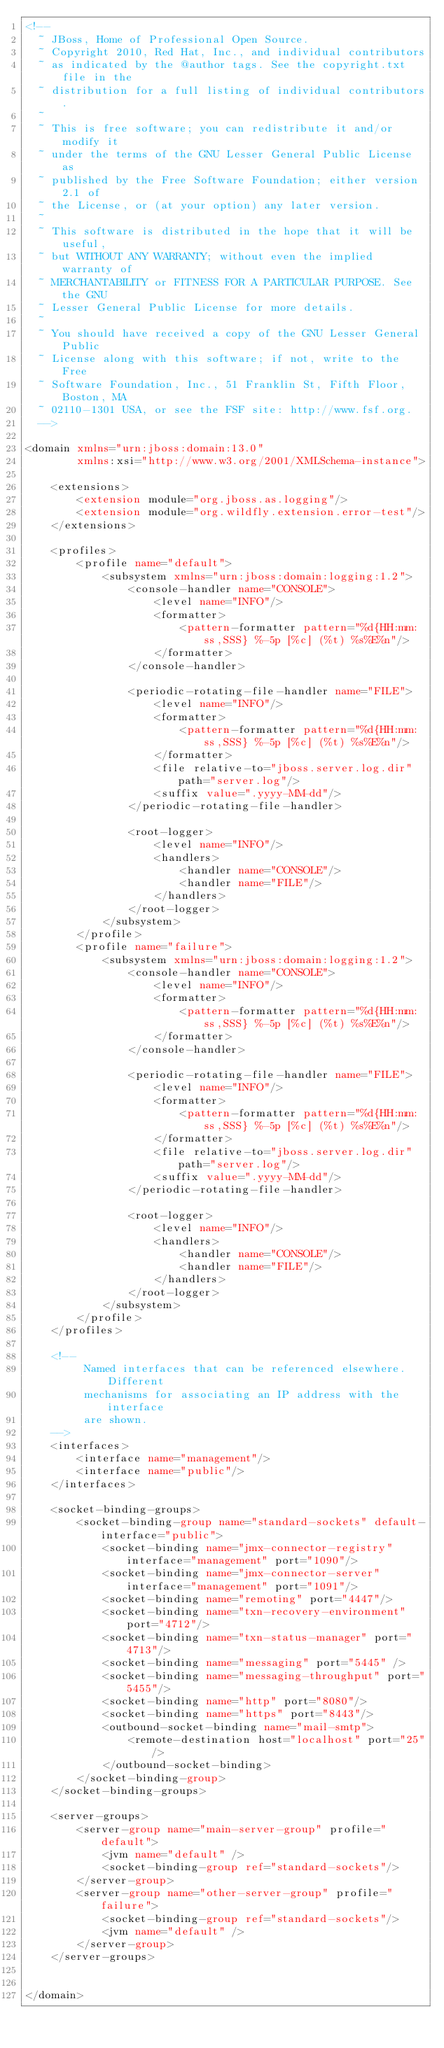Convert code to text. <code><loc_0><loc_0><loc_500><loc_500><_XML_><!--
  ~ JBoss, Home of Professional Open Source.
  ~ Copyright 2010, Red Hat, Inc., and individual contributors
  ~ as indicated by the @author tags. See the copyright.txt file in the
  ~ distribution for a full listing of individual contributors.
  ~
  ~ This is free software; you can redistribute it and/or modify it
  ~ under the terms of the GNU Lesser General Public License as
  ~ published by the Free Software Foundation; either version 2.1 of
  ~ the License, or (at your option) any later version.
  ~
  ~ This software is distributed in the hope that it will be useful,
  ~ but WITHOUT ANY WARRANTY; without even the implied warranty of
  ~ MERCHANTABILITY or FITNESS FOR A PARTICULAR PURPOSE. See the GNU
  ~ Lesser General Public License for more details.
  ~
  ~ You should have received a copy of the GNU Lesser General Public
  ~ License along with this software; if not, write to the Free
  ~ Software Foundation, Inc., 51 Franklin St, Fifth Floor, Boston, MA
  ~ 02110-1301 USA, or see the FSF site: http://www.fsf.org.
  -->

<domain xmlns="urn:jboss:domain:13.0"
        xmlns:xsi="http://www.w3.org/2001/XMLSchema-instance">

    <extensions>
        <extension module="org.jboss.as.logging"/>
        <extension module="org.wildfly.extension.error-test"/>
    </extensions>

    <profiles>
        <profile name="default">
            <subsystem xmlns="urn:jboss:domain:logging:1.2">
                <console-handler name="CONSOLE">
                    <level name="INFO"/>
                    <formatter>
                        <pattern-formatter pattern="%d{HH:mm:ss,SSS} %-5p [%c] (%t) %s%E%n"/>
                    </formatter>
                </console-handler>

                <periodic-rotating-file-handler name="FILE">
                    <level name="INFO"/>
                    <formatter>
                        <pattern-formatter pattern="%d{HH:mm:ss,SSS} %-5p [%c] (%t) %s%E%n"/>
                    </formatter>
                    <file relative-to="jboss.server.log.dir" path="server.log"/>
                    <suffix value=".yyyy-MM-dd"/>
                </periodic-rotating-file-handler>

                <root-logger>
                    <level name="INFO"/>
                    <handlers>
                        <handler name="CONSOLE"/>
                        <handler name="FILE"/>
                    </handlers>
                </root-logger>
            </subsystem>
        </profile>
        <profile name="failure">
            <subsystem xmlns="urn:jboss:domain:logging:1.2">
                <console-handler name="CONSOLE">
                    <level name="INFO"/>
                    <formatter>
                        <pattern-formatter pattern="%d{HH:mm:ss,SSS} %-5p [%c] (%t) %s%E%n"/>
                    </formatter>
                </console-handler>

                <periodic-rotating-file-handler name="FILE">
                    <level name="INFO"/>
                    <formatter>
                        <pattern-formatter pattern="%d{HH:mm:ss,SSS} %-5p [%c] (%t) %s%E%n"/>
                    </formatter>
                    <file relative-to="jboss.server.log.dir" path="server.log"/>
                    <suffix value=".yyyy-MM-dd"/>
                </periodic-rotating-file-handler>

                <root-logger>
                    <level name="INFO"/>
                    <handlers>
                        <handler name="CONSOLE"/>
                        <handler name="FILE"/>
                    </handlers>
                </root-logger>
            </subsystem>
        </profile>
    </profiles>

    <!--
         Named interfaces that can be referenced elsewhere. Different
         mechanisms for associating an IP address with the interface
         are shown.
    -->
    <interfaces>
        <interface name="management"/>
        <interface name="public"/>
    </interfaces>

    <socket-binding-groups>
        <socket-binding-group name="standard-sockets" default-interface="public">
            <socket-binding name="jmx-connector-registry" interface="management" port="1090"/>
            <socket-binding name="jmx-connector-server" interface="management" port="1091"/>
            <socket-binding name="remoting" port="4447"/>
            <socket-binding name="txn-recovery-environment" port="4712"/>
            <socket-binding name="txn-status-manager" port="4713"/>
            <socket-binding name="messaging" port="5445" />
            <socket-binding name="messaging-throughput" port="5455"/>
            <socket-binding name="http" port="8080"/>
            <socket-binding name="https" port="8443"/>
            <outbound-socket-binding name="mail-smtp">
                <remote-destination host="localhost" port="25"/>
            </outbound-socket-binding>
        </socket-binding-group>
    </socket-binding-groups>

    <server-groups>
        <server-group name="main-server-group" profile="default">
            <jvm name="default" />
            <socket-binding-group ref="standard-sockets"/>
        </server-group>
        <server-group name="other-server-group" profile="failure">
            <socket-binding-group ref="standard-sockets"/>
            <jvm name="default" />
        </server-group>
    </server-groups>


</domain>
</code> 